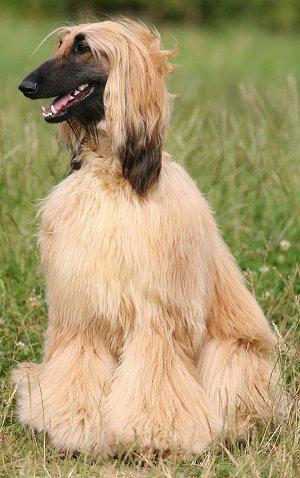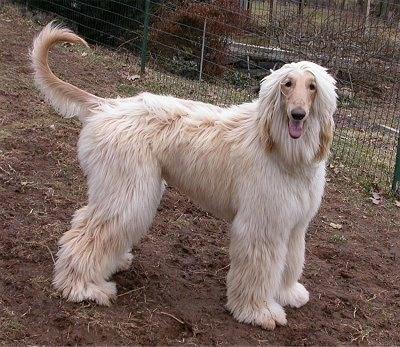The first image is the image on the left, the second image is the image on the right. Examine the images to the left and right. Is the description "There is at least one dog standing on all fours in the image on the left." accurate? Answer yes or no. No. The first image is the image on the left, the second image is the image on the right. Evaluate the accuracy of this statement regarding the images: "In one image there is a lone afghan hound standing outside". Is it true? Answer yes or no. Yes. The first image is the image on the left, the second image is the image on the right. Given the left and right images, does the statement "An image shows a standing dog with a leash attached." hold true? Answer yes or no. No. 